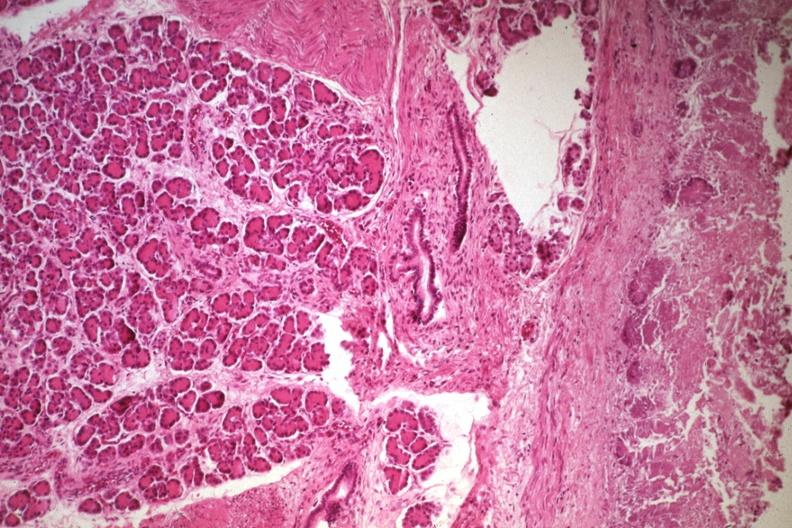s gastrointestinal present?
Answer the question using a single word or phrase. Yes 